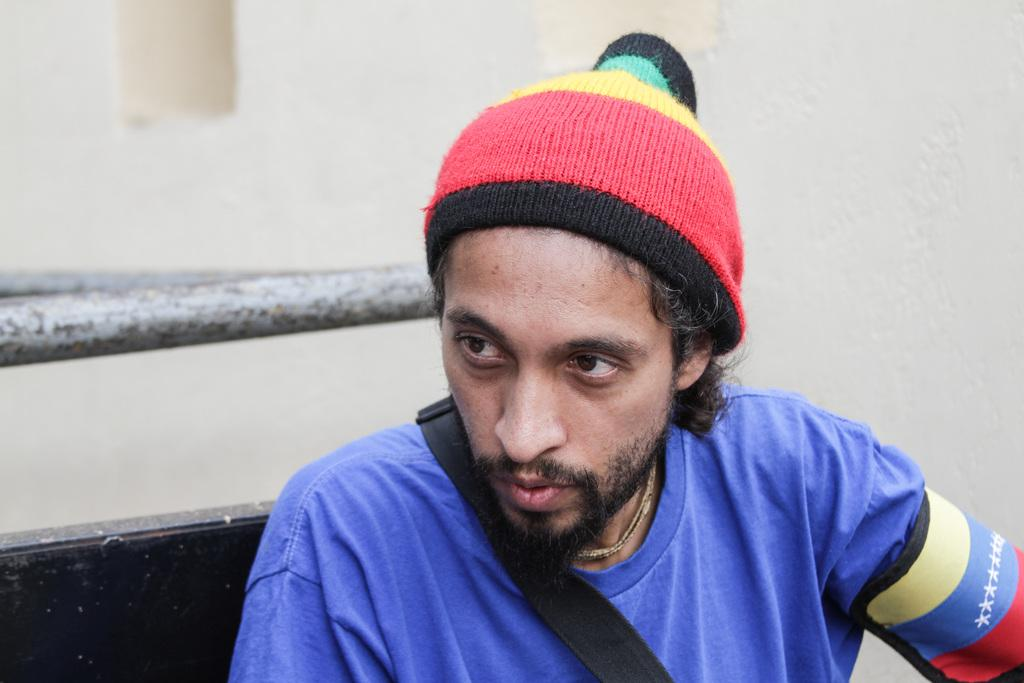What is present in the image? There is a man in the image. What is the man wearing? The man is wearing clothes, a cap, and a chain. What can be seen in the background of the image? There is a wall in the image. How many toes are visible on the man's feet in the image? The image does not show the man's feet, so it is not possible to determine the number of toes visible. 